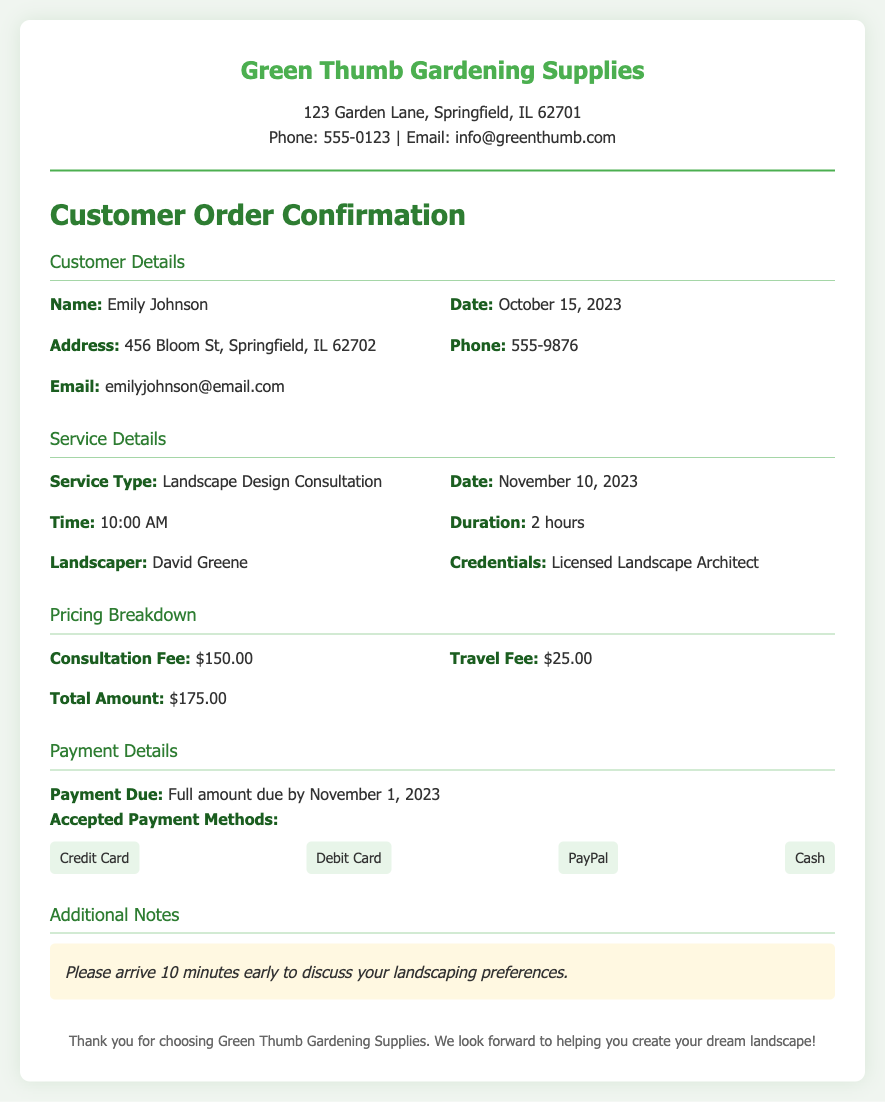What is the name of the customer? The document lists the name of the customer under "Customer Details" as Emily Johnson.
Answer: Emily Johnson What date is the landscape design consultation scheduled for? The scheduled date for the consultation is found in the "Service Details" section, which states November 10, 2023.
Answer: November 10, 2023 How much is the consultation fee? The consultation fee is specified in the "Pricing Breakdown" section as $150.00.
Answer: $150.00 Who is the landscaper? The document identifies the landscaper responsible for the consultation as David Greene in the "Service Details" section.
Answer: David Greene What is the total amount due? The total amount due can be found in the "Pricing Breakdown" section, which states it as $175.00.
Answer: $175.00 When is the payment due? The payment due date is mentioned in the "Payment Details" section as November 1, 2023.
Answer: November 1, 2023 What payment methods are accepted? The document lists accepted payment methods under "Payment Details" which includes Credit Card, Debit Card, PayPal, and Cash.
Answer: Credit Card, Debit Card, PayPal, Cash What is the recommended arrival time? The "Additional Notes" section recommends arriving 10 minutes early to discuss landscaping preferences.
Answer: 10 minutes early What is the duration of the consultation? The duration is specified in the "Service Details" section as 2 hours.
Answer: 2 hours 